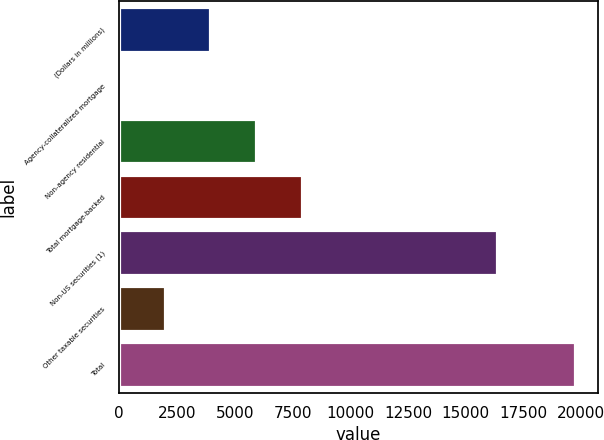Convert chart to OTSL. <chart><loc_0><loc_0><loc_500><loc_500><bar_chart><fcel>(Dollars in millions)<fcel>Agency-collateralized mortgage<fcel>Non-agency residential<fcel>Total mortgage-backed<fcel>Non-US securities (1)<fcel>Other taxable securities<fcel>Total<nl><fcel>3948<fcel>5<fcel>5919.5<fcel>7891<fcel>16336<fcel>1976.5<fcel>19720<nl></chart> 